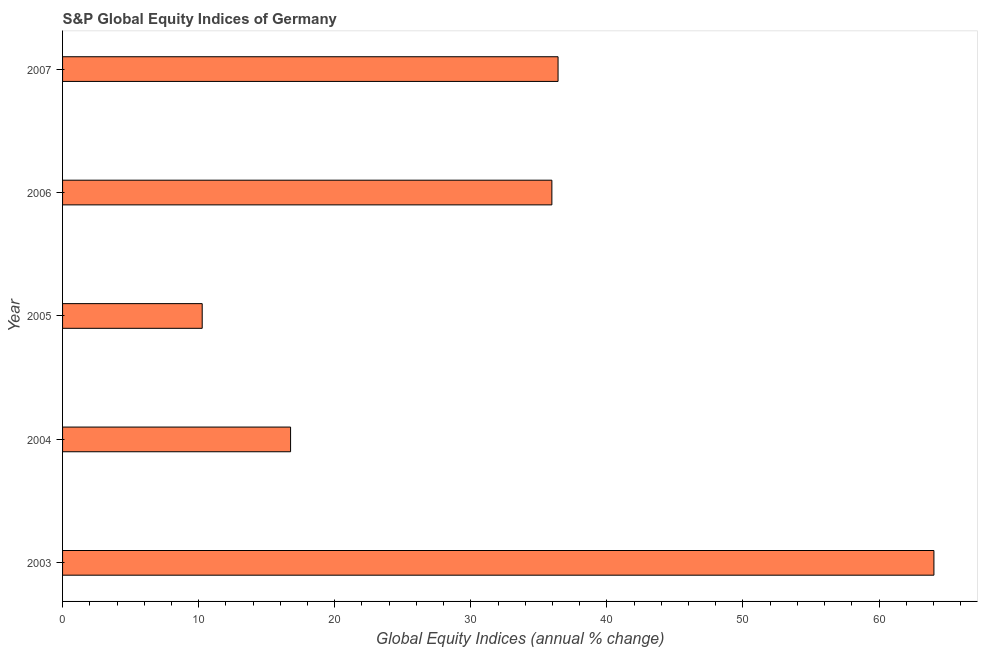What is the title of the graph?
Keep it short and to the point. S&P Global Equity Indices of Germany. What is the label or title of the X-axis?
Make the answer very short. Global Equity Indices (annual % change). What is the label or title of the Y-axis?
Provide a short and direct response. Year. What is the s&p global equity indices in 2004?
Make the answer very short. 16.75. Across all years, what is the maximum s&p global equity indices?
Keep it short and to the point. 64.03. Across all years, what is the minimum s&p global equity indices?
Make the answer very short. 10.26. In which year was the s&p global equity indices maximum?
Your response must be concise. 2003. What is the sum of the s&p global equity indices?
Your answer should be very brief. 163.41. What is the difference between the s&p global equity indices in 2003 and 2005?
Ensure brevity in your answer.  53.77. What is the average s&p global equity indices per year?
Offer a very short reply. 32.68. What is the median s&p global equity indices?
Ensure brevity in your answer.  35.96. What is the ratio of the s&p global equity indices in 2003 to that in 2006?
Provide a short and direct response. 1.78. What is the difference between the highest and the second highest s&p global equity indices?
Offer a very short reply. 27.62. Is the sum of the s&p global equity indices in 2004 and 2006 greater than the maximum s&p global equity indices across all years?
Your answer should be compact. No. What is the difference between the highest and the lowest s&p global equity indices?
Provide a short and direct response. 53.77. In how many years, is the s&p global equity indices greater than the average s&p global equity indices taken over all years?
Give a very brief answer. 3. How many years are there in the graph?
Provide a short and direct response. 5. What is the difference between two consecutive major ticks on the X-axis?
Your answer should be compact. 10. What is the Global Equity Indices (annual % change) in 2003?
Offer a very short reply. 64.03. What is the Global Equity Indices (annual % change) of 2004?
Your answer should be very brief. 16.75. What is the Global Equity Indices (annual % change) of 2005?
Give a very brief answer. 10.26. What is the Global Equity Indices (annual % change) in 2006?
Your answer should be very brief. 35.96. What is the Global Equity Indices (annual % change) in 2007?
Ensure brevity in your answer.  36.41. What is the difference between the Global Equity Indices (annual % change) in 2003 and 2004?
Keep it short and to the point. 47.28. What is the difference between the Global Equity Indices (annual % change) in 2003 and 2005?
Ensure brevity in your answer.  53.77. What is the difference between the Global Equity Indices (annual % change) in 2003 and 2006?
Keep it short and to the point. 28.07. What is the difference between the Global Equity Indices (annual % change) in 2003 and 2007?
Provide a short and direct response. 27.62. What is the difference between the Global Equity Indices (annual % change) in 2004 and 2005?
Offer a very short reply. 6.49. What is the difference between the Global Equity Indices (annual % change) in 2004 and 2006?
Offer a terse response. -19.2. What is the difference between the Global Equity Indices (annual % change) in 2004 and 2007?
Provide a succinct answer. -19.66. What is the difference between the Global Equity Indices (annual % change) in 2005 and 2006?
Offer a very short reply. -25.7. What is the difference between the Global Equity Indices (annual % change) in 2005 and 2007?
Give a very brief answer. -26.15. What is the difference between the Global Equity Indices (annual % change) in 2006 and 2007?
Provide a succinct answer. -0.45. What is the ratio of the Global Equity Indices (annual % change) in 2003 to that in 2004?
Your response must be concise. 3.82. What is the ratio of the Global Equity Indices (annual % change) in 2003 to that in 2005?
Keep it short and to the point. 6.24. What is the ratio of the Global Equity Indices (annual % change) in 2003 to that in 2006?
Offer a terse response. 1.78. What is the ratio of the Global Equity Indices (annual % change) in 2003 to that in 2007?
Make the answer very short. 1.76. What is the ratio of the Global Equity Indices (annual % change) in 2004 to that in 2005?
Your response must be concise. 1.63. What is the ratio of the Global Equity Indices (annual % change) in 2004 to that in 2006?
Your answer should be very brief. 0.47. What is the ratio of the Global Equity Indices (annual % change) in 2004 to that in 2007?
Make the answer very short. 0.46. What is the ratio of the Global Equity Indices (annual % change) in 2005 to that in 2006?
Offer a very short reply. 0.28. What is the ratio of the Global Equity Indices (annual % change) in 2005 to that in 2007?
Offer a very short reply. 0.28. What is the ratio of the Global Equity Indices (annual % change) in 2006 to that in 2007?
Give a very brief answer. 0.99. 